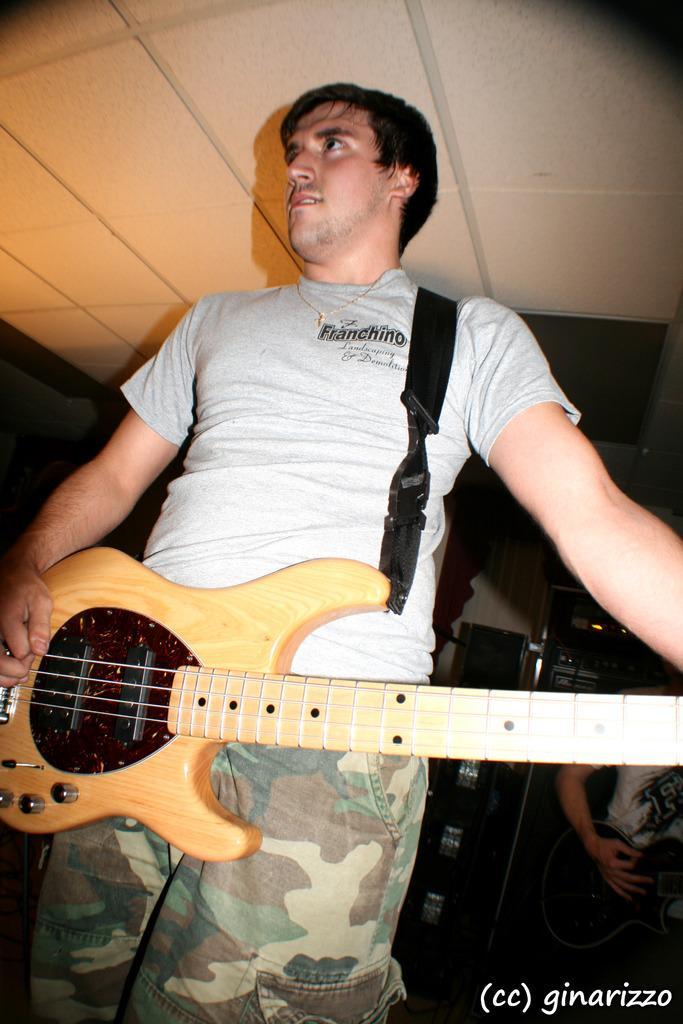Can you describe this image briefly? In the image we can see there are two persons who are holding the guitar in their hands. 